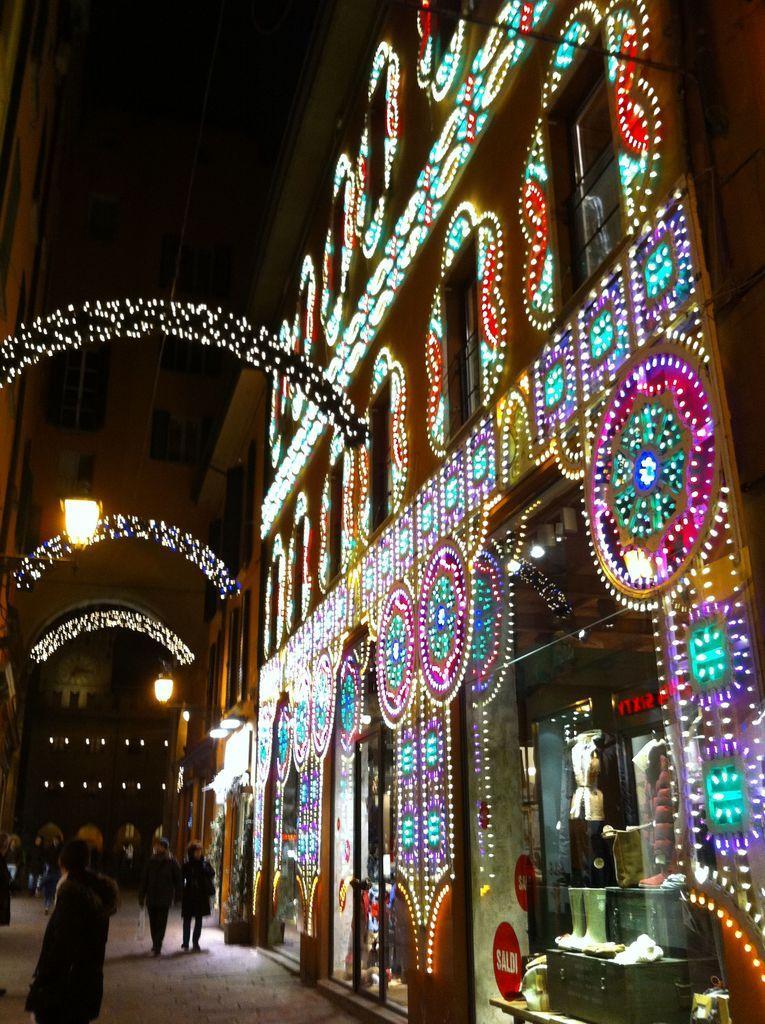Could you give a brief overview of what you see in this image? In this image we can see a group of people standing on the ground, some plants. To the right side of the image we can see a container and some objects placed on the table. In the background, we can see buildings with doors, windows and group of lights. 